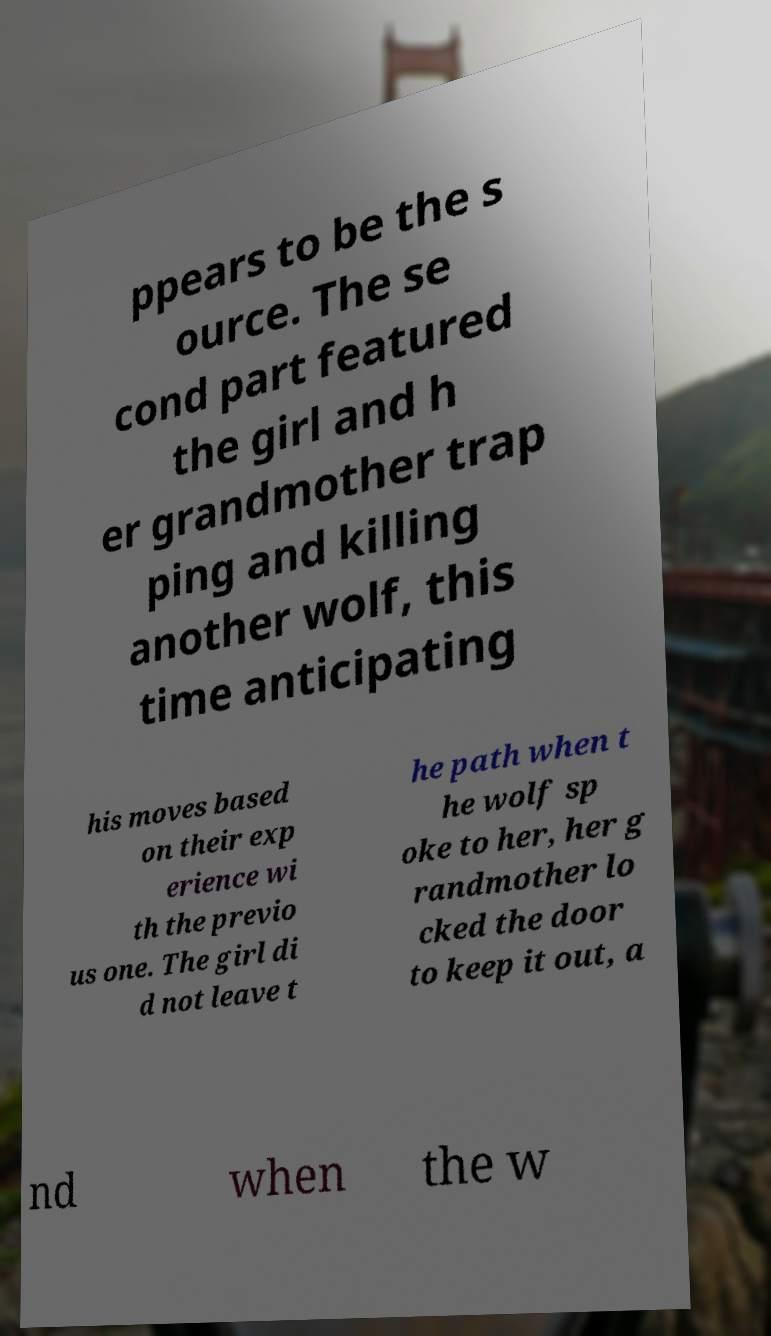Can you accurately transcribe the text from the provided image for me? ppears to be the s ource. The se cond part featured the girl and h er grandmother trap ping and killing another wolf, this time anticipating his moves based on their exp erience wi th the previo us one. The girl di d not leave t he path when t he wolf sp oke to her, her g randmother lo cked the door to keep it out, a nd when the w 